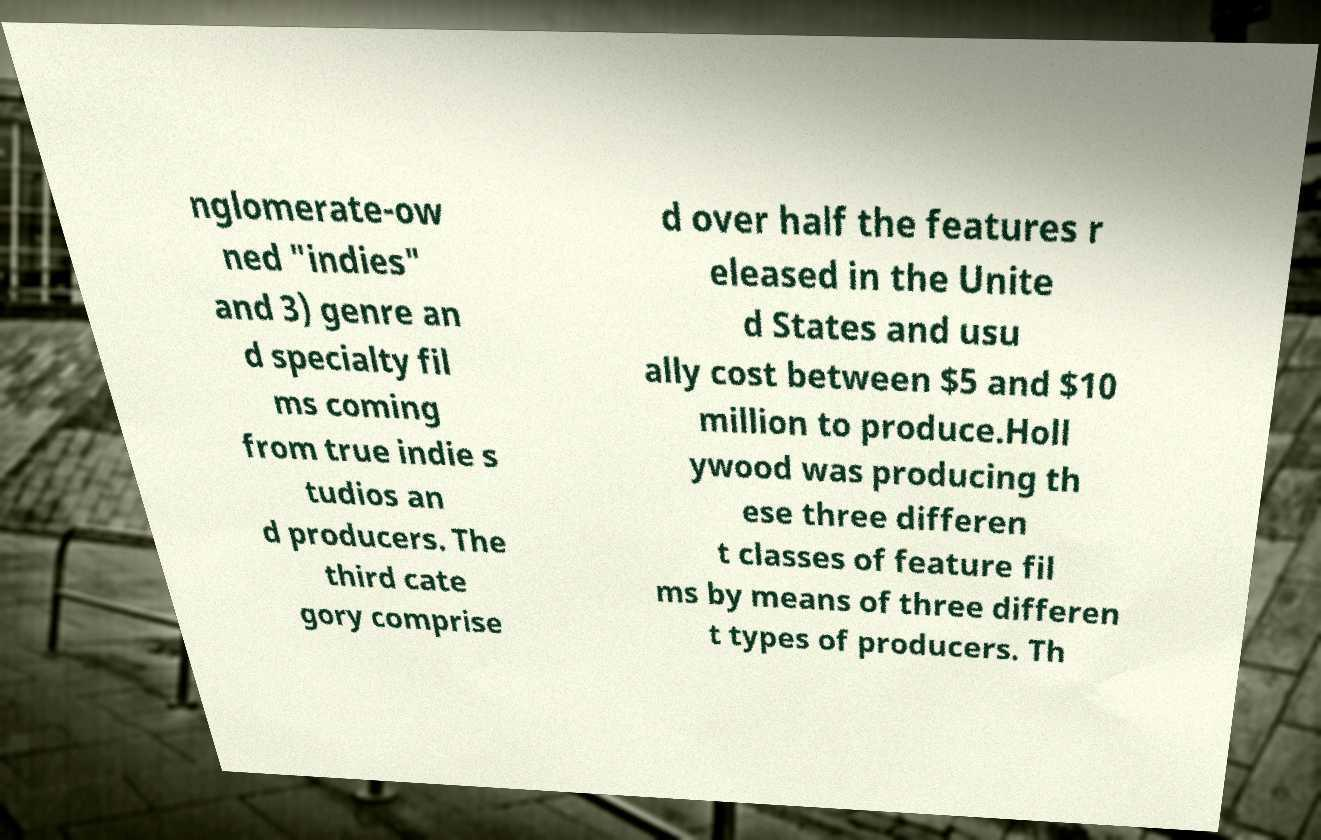Can you accurately transcribe the text from the provided image for me? nglomerate-ow ned "indies" and 3) genre an d specialty fil ms coming from true indie s tudios an d producers. The third cate gory comprise d over half the features r eleased in the Unite d States and usu ally cost between $5 and $10 million to produce.Holl ywood was producing th ese three differen t classes of feature fil ms by means of three differen t types of producers. Th 